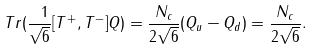<formula> <loc_0><loc_0><loc_500><loc_500>T r ( \frac { \ 1 } { \sqrt { 6 } } [ T ^ { + } , T ^ { - } ] Q ) = \frac { N _ { c } } { 2 \sqrt { 6 } } ( Q _ { u } - Q _ { d } ) = \frac { N _ { c } } { 2 \sqrt { 6 } } .</formula> 